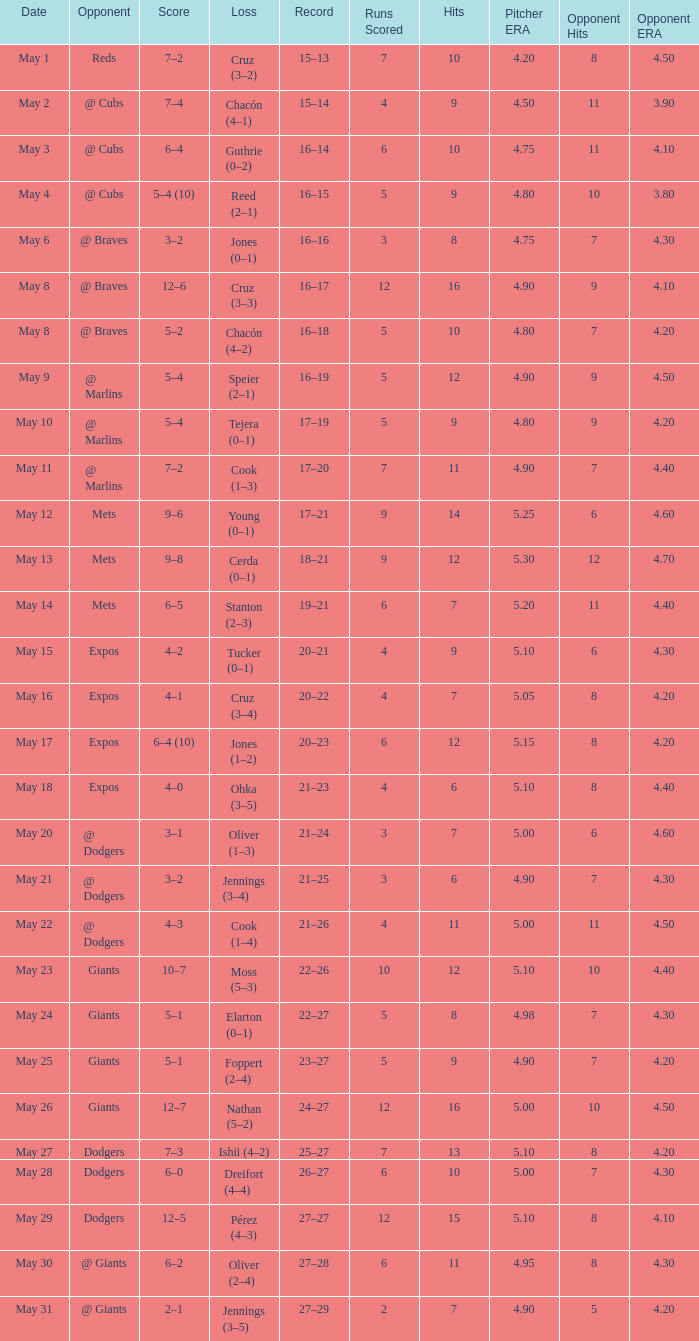Tell me who was the opponent on May 6 @ Braves. 